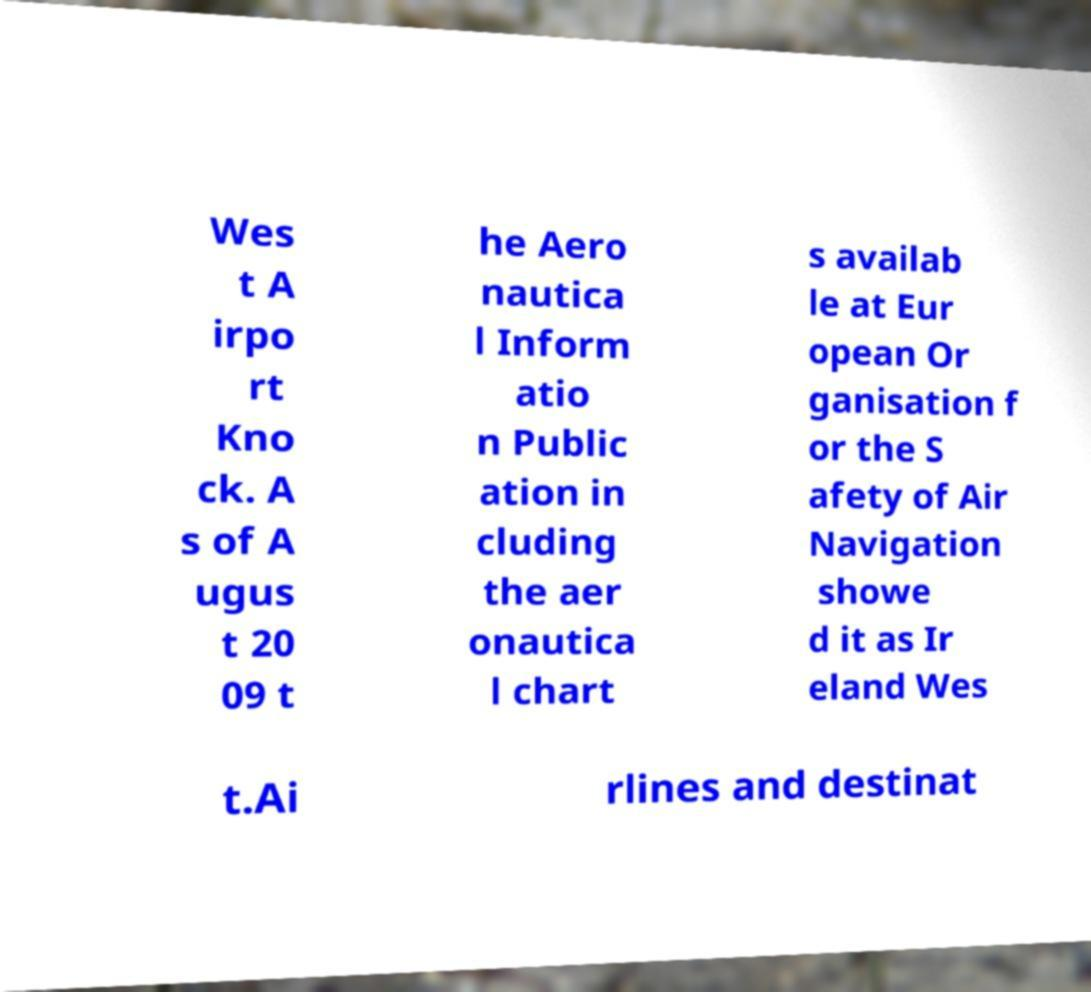Can you accurately transcribe the text from the provided image for me? Wes t A irpo rt Kno ck. A s of A ugus t 20 09 t he Aero nautica l Inform atio n Public ation in cluding the aer onautica l chart s availab le at Eur opean Or ganisation f or the S afety of Air Navigation showe d it as Ir eland Wes t.Ai rlines and destinat 